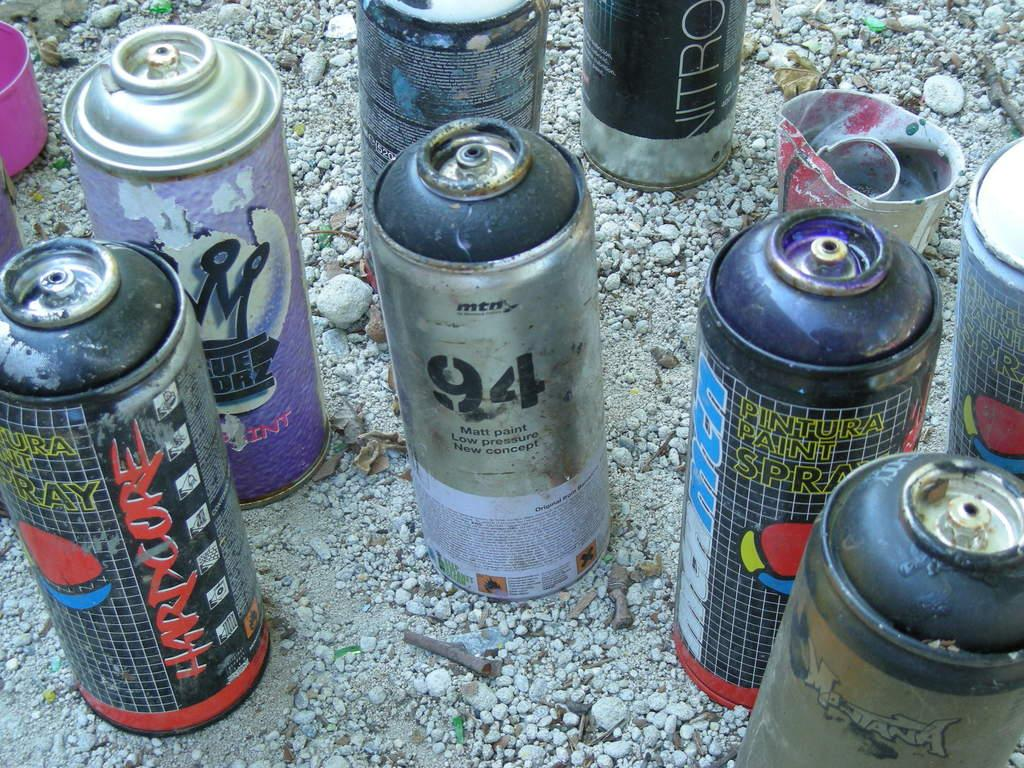Provide a one-sentence caption for the provided image. Different kinds of old spray paint cans sit in the gravel. The word Hardcore is written across the side of one. 